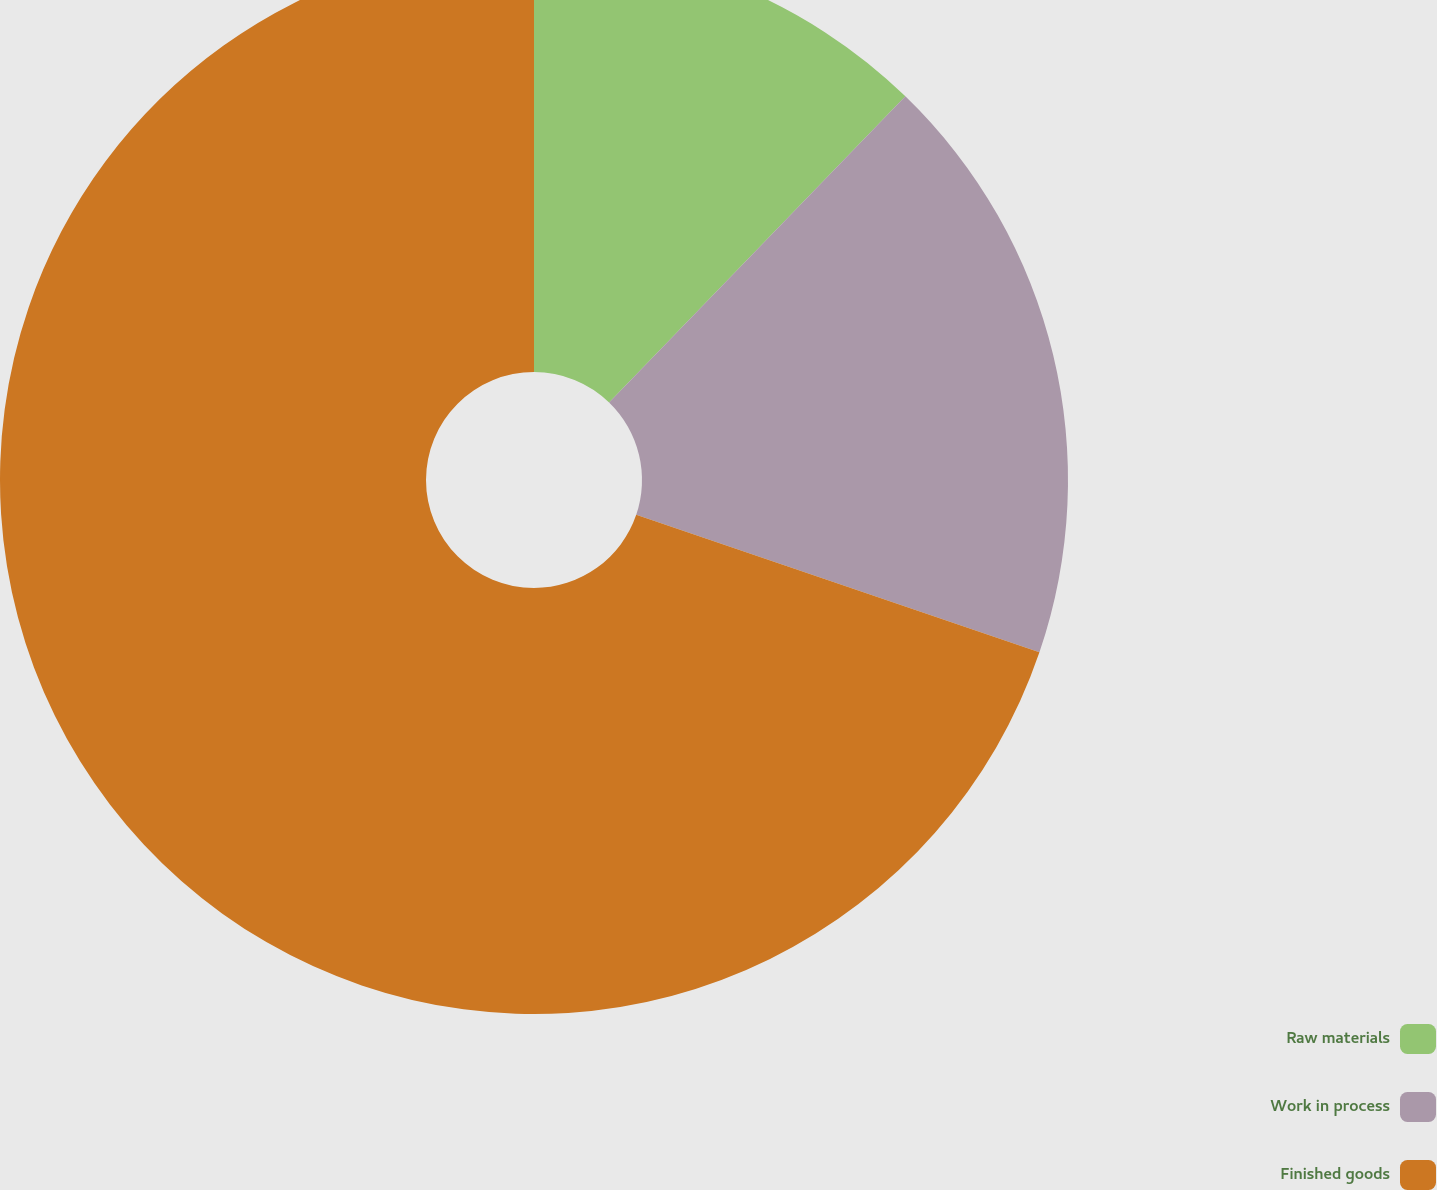Convert chart to OTSL. <chart><loc_0><loc_0><loc_500><loc_500><pie_chart><fcel>Raw materials<fcel>Work in process<fcel>Finished goods<nl><fcel>12.24%<fcel>17.99%<fcel>69.77%<nl></chart> 